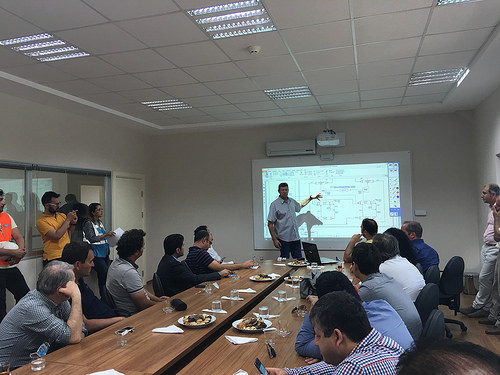<image>
Is there a man in front of the table? Yes. The man is positioned in front of the table, appearing closer to the camera viewpoint. 